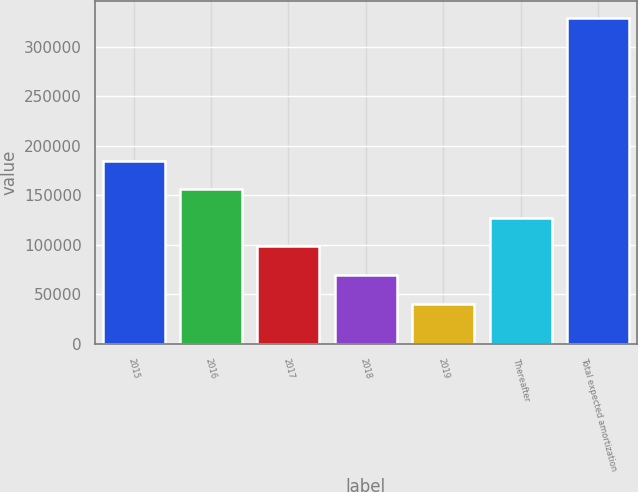<chart> <loc_0><loc_0><loc_500><loc_500><bar_chart><fcel>2015<fcel>2016<fcel>2017<fcel>2018<fcel>2019<fcel>Thereafter<fcel>Total expected amortization<nl><fcel>184880<fcel>156026<fcel>98318.2<fcel>69464.1<fcel>40610<fcel>127172<fcel>329151<nl></chart> 